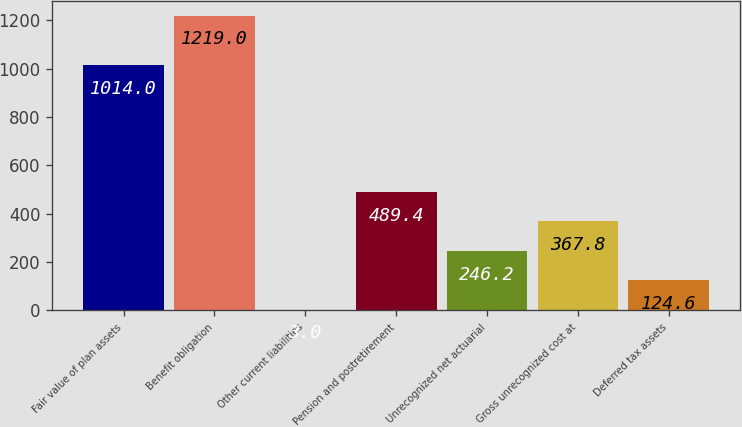Convert chart. <chart><loc_0><loc_0><loc_500><loc_500><bar_chart><fcel>Fair value of plan assets<fcel>Benefit obligation<fcel>Other current liabilities<fcel>Pension and postretirement<fcel>Unrecognized net actuarial<fcel>Gross unrecognized cost at<fcel>Deferred tax assets<nl><fcel>1014<fcel>1219<fcel>3<fcel>489.4<fcel>246.2<fcel>367.8<fcel>124.6<nl></chart> 